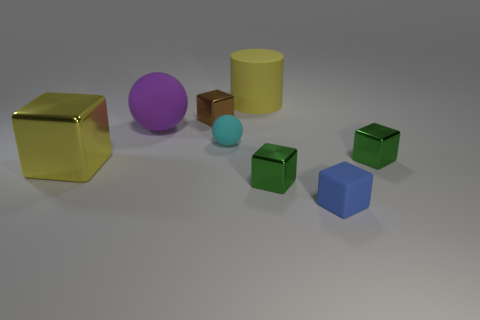Is there a rubber cylinder of the same color as the small rubber sphere?
Your answer should be compact. No. There is a tiny green thing that is to the left of the rubber cube; is it the same shape as the blue thing?
Offer a very short reply. Yes. What number of other things have the same size as the brown metal object?
Ensure brevity in your answer.  4. There is a big yellow object that is in front of the large matte cylinder; what number of large yellow cylinders are to the right of it?
Provide a succinct answer. 1. Are the cube behind the big rubber ball and the yellow cylinder made of the same material?
Your answer should be very brief. No. Do the green object that is on the left side of the tiny matte cube and the large yellow object that is behind the big yellow block have the same material?
Make the answer very short. No. Is the number of yellow things that are in front of the purple rubber ball greater than the number of tiny blue rubber balls?
Ensure brevity in your answer.  Yes. What is the color of the tiny rubber thing left of the green thing that is on the left side of the tiny blue object?
Keep it short and to the point. Cyan. There is a cyan rubber object that is the same size as the brown metallic cube; what shape is it?
Keep it short and to the point. Sphere. There is a metallic thing that is the same color as the big rubber cylinder; what shape is it?
Your response must be concise. Cube. 